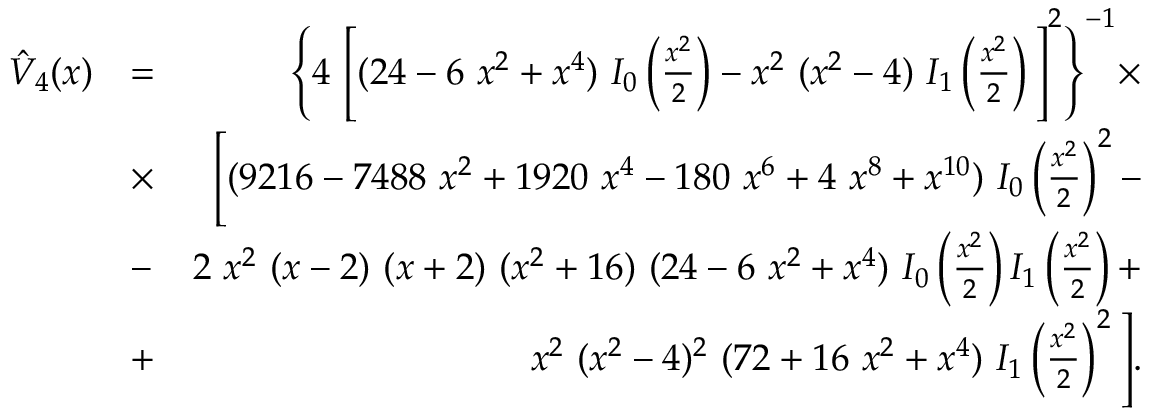Convert formula to latex. <formula><loc_0><loc_0><loc_500><loc_500>\begin{array} { r l r } { \hat { V } _ { 4 } ( x ) } & { = } & { \left \{ 4 \left [ ( 2 4 - 6 x ^ { 2 } + x ^ { 4 } ) I _ { 0 } \left ( \frac { x ^ { 2 } } { 2 } \right ) - x ^ { 2 } ( x ^ { 2 } - 4 ) I _ { 1 } \left ( \frac { x ^ { 2 } } { 2 } \right ) \right ] ^ { 2 } \right \} ^ { - 1 } \times } \\ & { \times } & { \left [ ( 9 2 1 6 - 7 4 8 8 x ^ { 2 } + 1 9 2 0 x ^ { 4 } - 1 8 0 x ^ { 6 } + 4 x ^ { 8 } + x ^ { 1 0 } ) I _ { 0 } \left ( \frac { x ^ { 2 } } { 2 } \right ) ^ { 2 } - } \\ & { - } & { 2 x ^ { 2 } ( x - 2 ) ( x + 2 ) ( x ^ { 2 } + 1 6 ) ( 2 4 - 6 x ^ { 2 } + x ^ { 4 } ) I _ { 0 } \left ( \frac { x ^ { 2 } } { 2 } \right ) I _ { 1 } \left ( \frac { x ^ { 2 } } { 2 } \right ) + } \\ & { + } & { x ^ { 2 } ( x ^ { 2 } - 4 ) ^ { 2 } ( 7 2 + 1 6 x ^ { 2 } + x ^ { 4 } ) I _ { 1 } \left ( \frac { x ^ { 2 } } { 2 } \right ) ^ { 2 } \right ] . } \end{array}</formula> 